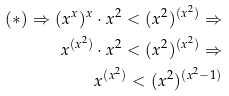<formula> <loc_0><loc_0><loc_500><loc_500>& & ( \ast ) \Rightarrow ( x ^ { x } ) ^ { x } \cdot x ^ { 2 } < ( x ^ { 2 } ) ^ { ( x ^ { 2 } ) } \Rightarrow \\ & & x ^ { ( x ^ { 2 } ) } \cdot x ^ { 2 } < ( x ^ { 2 } ) ^ { ( x ^ { 2 } ) } \Rightarrow \\ & & x ^ { ( x ^ { 2 } ) } < ( x ^ { 2 } ) ^ { ( x ^ { 2 } - 1 ) }</formula> 